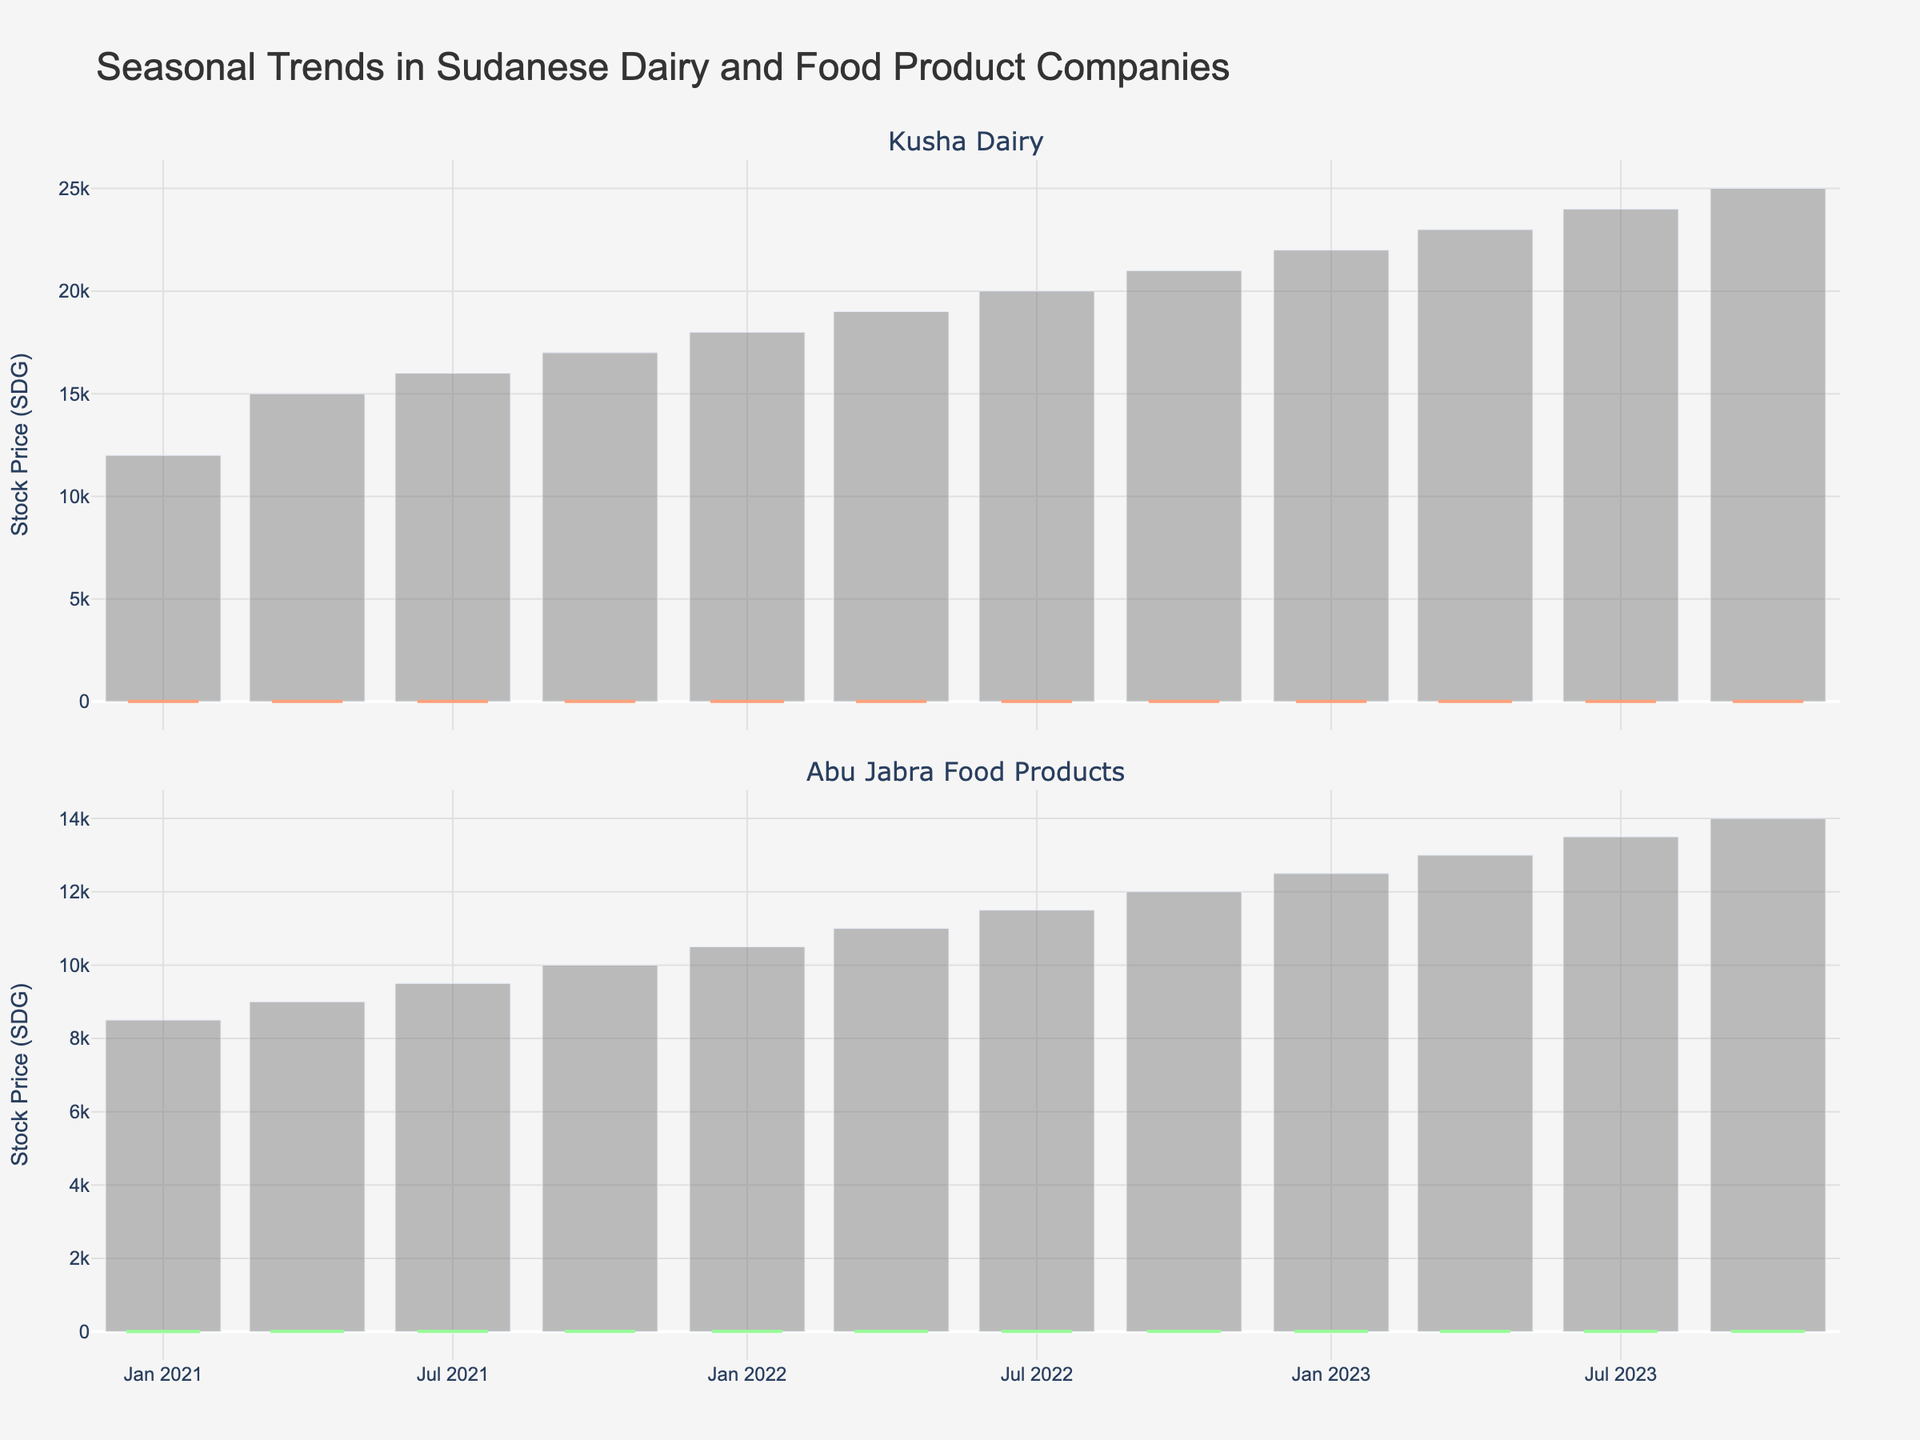What is the title of the figure? The title appears at the top of the figure and provides an overall description of the chart.
Answer: Seasonal Trends in Sudanese Dairy and Food Product Companies How many companies are displayed in the figure? The figure shows two separate candlestick plots, each representing a different company.
Answer: Two What is the trend in the closing prices for Kusha Dairy over the three-year period? To identify the trend, observe the closing prices for Kusha Dairy from the beginning to the end of the three years. The prices generally increase from 5.60 to 7.50.
Answer: Increasing Which company has a higher stock price at the end of the period? Compare the closing prices of Kusha Dairy and Abu Jabra Food Products on the last date (2023-10-01). Kusha Dairy closes at 7.50, while Abu Jabra Food Products closes at 5.15.
Answer: Kusha Dairy What is the volume of trades for Abu Jabra Food Products on 2023-07-01? Look at the bar chart for Abu Jabra Food Products around 2023-07-01 and identify the value associated with the volume.
Answer: 13,500 By how much did Kusha Dairy's stock price increase from 2021-01-01 to 2023-10-01? Subtract the closing price on 2021-01-01 (5.60) from the closing price on 2023-10-01 (7.50). The increase is 7.50 - 5.60.
Answer: 1.90 Which company shows more seasonal variation in stock prices? Observe the fluctuations in the candlestick charts for both companies. Kusha Dairy shows more distinct seasonal patterns with more pronounced highs and lows compared to Abu Jabra Food Products.
Answer: Kusha Dairy In which quarter does Abu Jabra Food Products have the highest closing price? Check each candlestick for Abu Jabra Food Products to find the highest closing price. The highest closing price (5.15) occurs in 2023-10-01.
Answer: Q4 2023 When did Kusha Dairy have the highest trading volume? Examine the bar charts under the Kusha Dairy plot to find the highest bar representing the trading volume. The highest volume is observed on 2023-10-01.
Answer: 2023-10-01 What are the low and high prices of Kusha Dairy on 2022-07-01? Refer to the candlestick for Kusha Dairy on 2022-07-01. The low and high prices are indicated by the bottom and top of the candlestick's wick, which are 6.40 and 6.75 respectively.
Answer: 6.40 and 6.75 